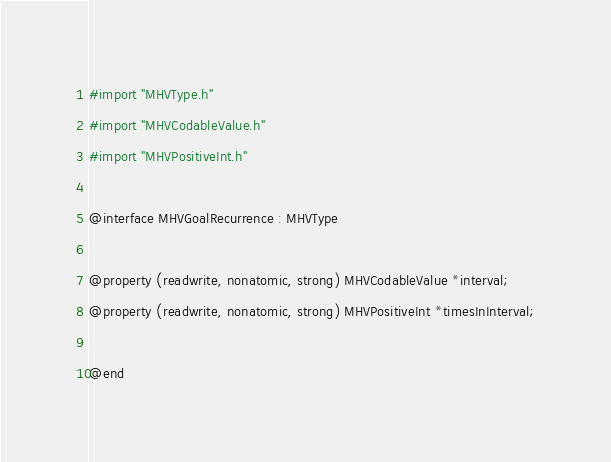Convert code to text. <code><loc_0><loc_0><loc_500><loc_500><_C_>
#import "MHVType.h"
#import "MHVCodableValue.h"
#import "MHVPositiveInt.h"

@interface MHVGoalRecurrence : MHVType

@property (readwrite, nonatomic, strong) MHVCodableValue *interval;
@property (readwrite, nonatomic, strong) MHVPositiveInt *timesInInterval;

@end
</code> 